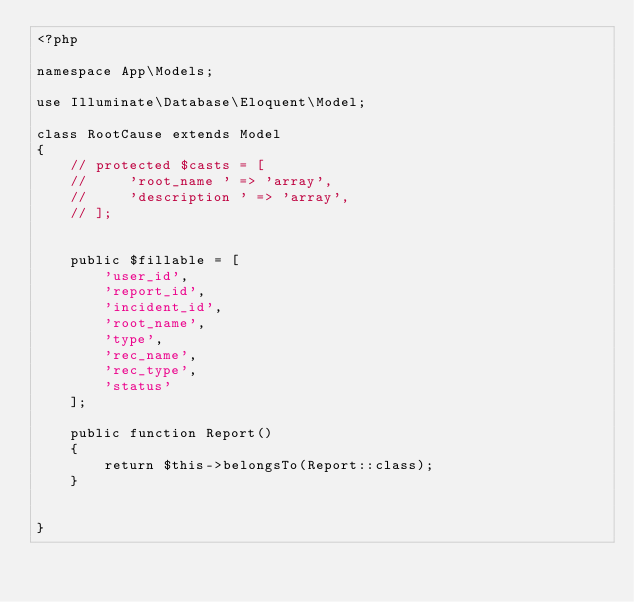<code> <loc_0><loc_0><loc_500><loc_500><_PHP_><?php

namespace App\Models;

use Illuminate\Database\Eloquent\Model;

class RootCause extends Model
{
    // protected $casts = [
    //     'root_name ' => 'array',
    //     'description ' => 'array',
    // ];


    public $fillable = [
        'user_id',
        'report_id',
        'incident_id',
        'root_name',
        'type',
        'rec_name',
        'rec_type',
        'status'
    ];

    public function Report()
    {
        return $this->belongsTo(Report::class);
    }

    
}
</code> 